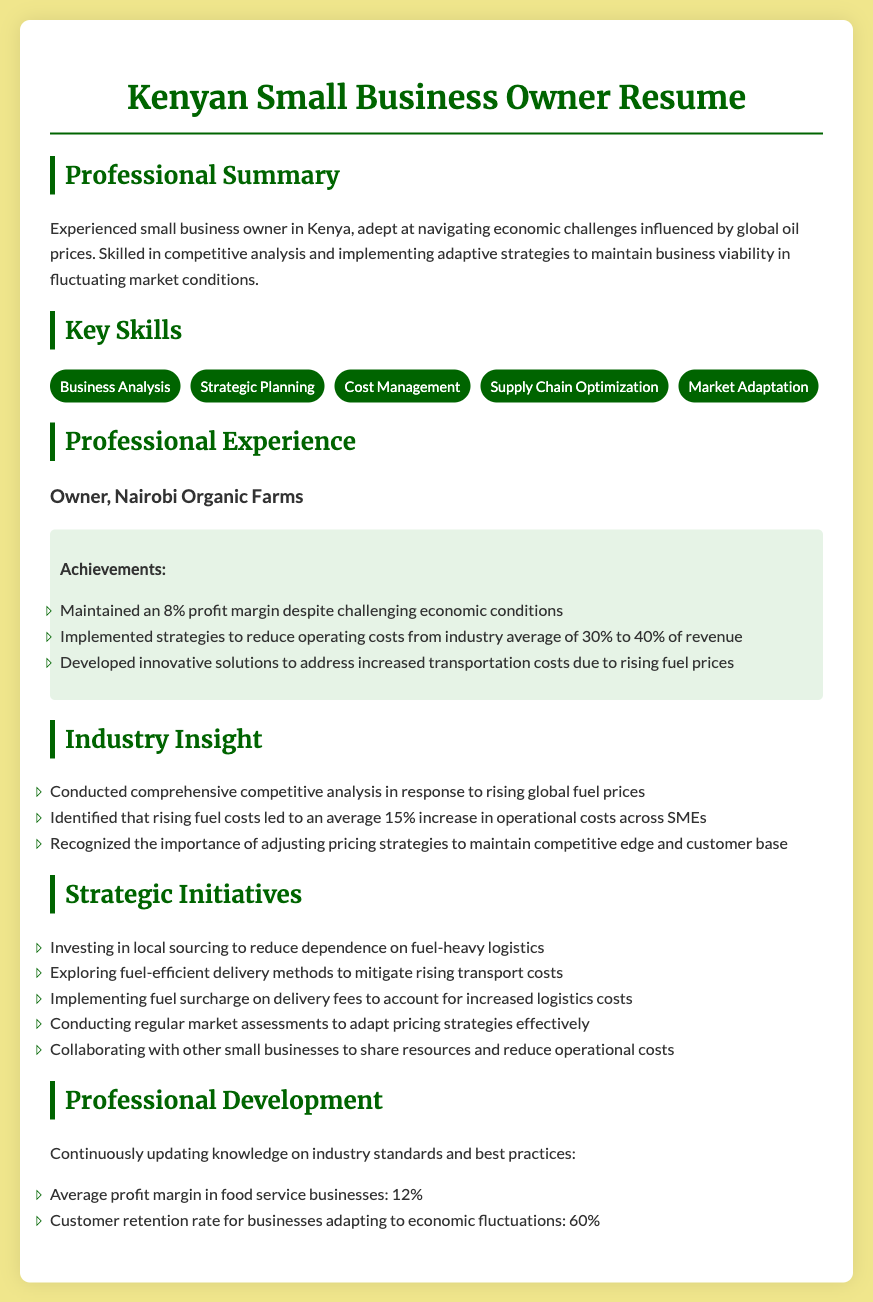what is the profit margin maintained by Nairobi Organic Farms? The document states that Nairobi Organic Farms maintained an 8% profit margin despite challenging economic conditions.
Answer: 8% what average percentage of operational costs increased for SMEs due to rising fuel prices? The document mentions that rising fuel costs led to an average 15% increase in operational costs across SMEs.
Answer: 15% what is one strategic initiative undertaken to reduce fuel reliance? The document lists several initiatives, one of which is investing in local sourcing to reduce dependence on fuel-heavy logistics.
Answer: investing in local sourcing what industry standard average profit margin is mentioned for food service businesses? The professional development section cites the average profit margin in food service businesses as 12%.
Answer: 12% what is the customer retention rate for businesses adapting to economic fluctuations according to the document? The document states that the customer retention rate for businesses adapting to economic fluctuations is 60%.
Answer: 60% how much did the owner reduce operating costs from the industry average? The document specifies that costs were reduced from the industry average of 30% to 40% of revenue.
Answer: 30% to 40% what color is used for the headings in the document? The headings are styled with the color #006400.
Answer: #006400 which business does the resume pertain to? The resume pertains to Nairobi Organic Farms, as indicated in the professional experience section.
Answer: Nairobi Organic Farms what is one method explored to mitigate transportation cost increases? The resume mentions exploring fuel-efficient delivery methods to mitigate rising transport costs.
Answer: fuel-efficient delivery methods 